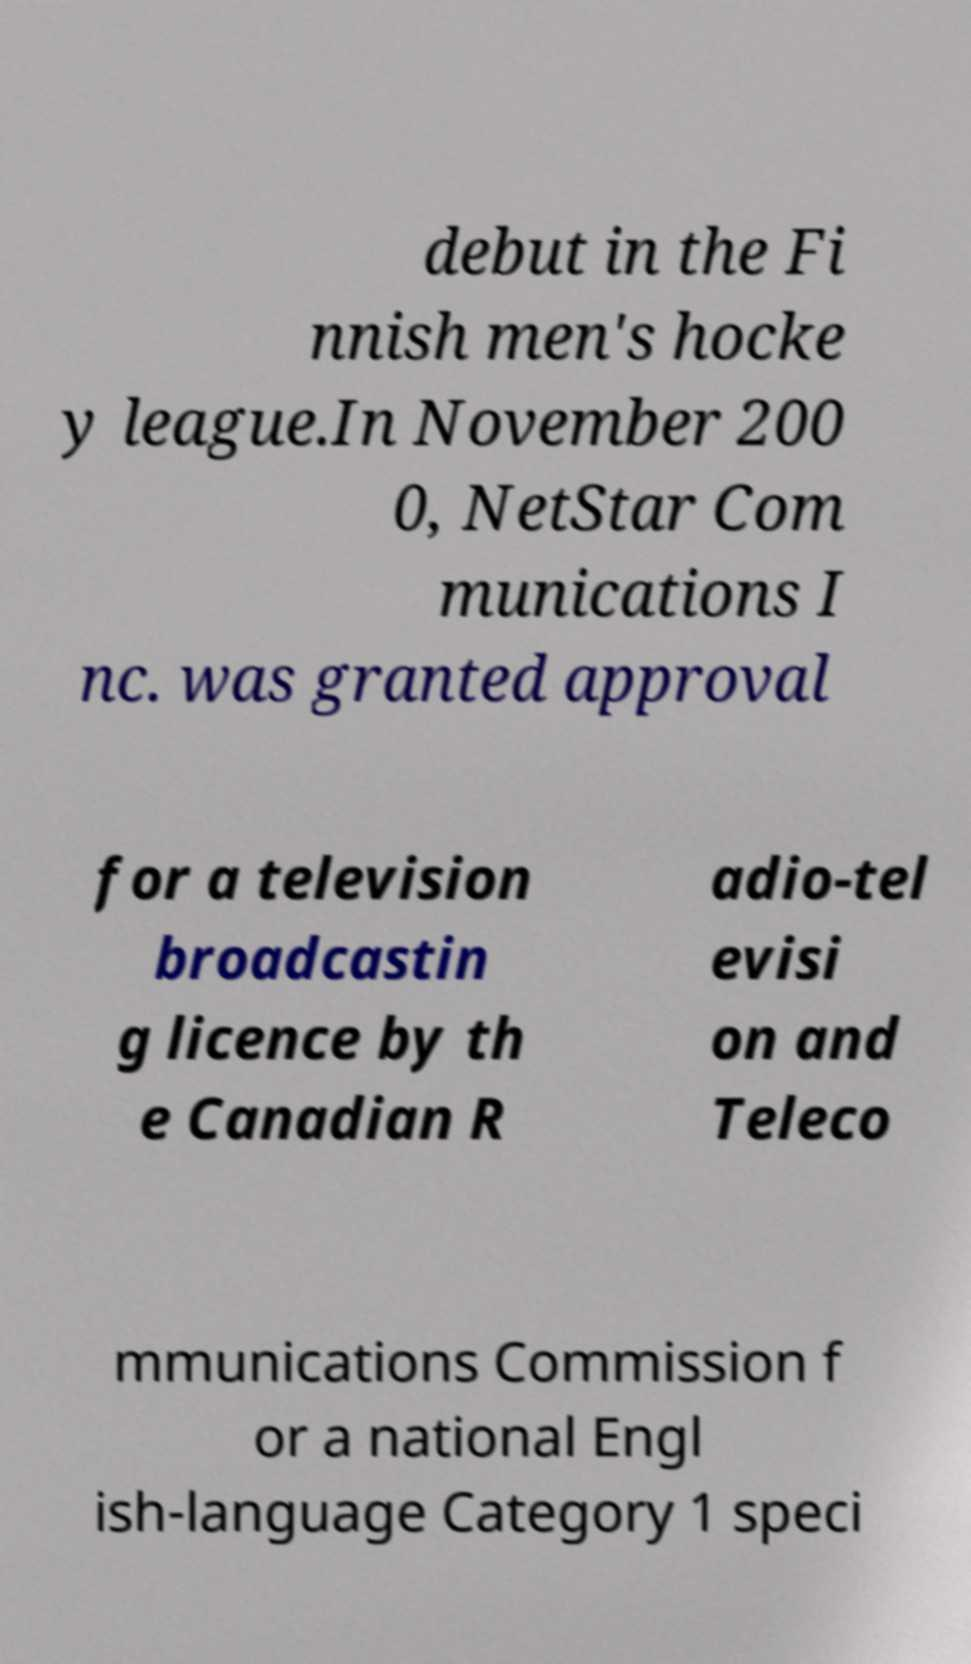Can you read and provide the text displayed in the image?This photo seems to have some interesting text. Can you extract and type it out for me? debut in the Fi nnish men's hocke y league.In November 200 0, NetStar Com munications I nc. was granted approval for a television broadcastin g licence by th e Canadian R adio-tel evisi on and Teleco mmunications Commission f or a national Engl ish-language Category 1 speci 